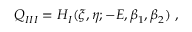Convert formula to latex. <formula><loc_0><loc_0><loc_500><loc_500>Q _ { I I I } = H _ { I } ( \xi , \eta ; - E , \beta _ { 1 } , \beta _ { 2 } ) \ ,</formula> 